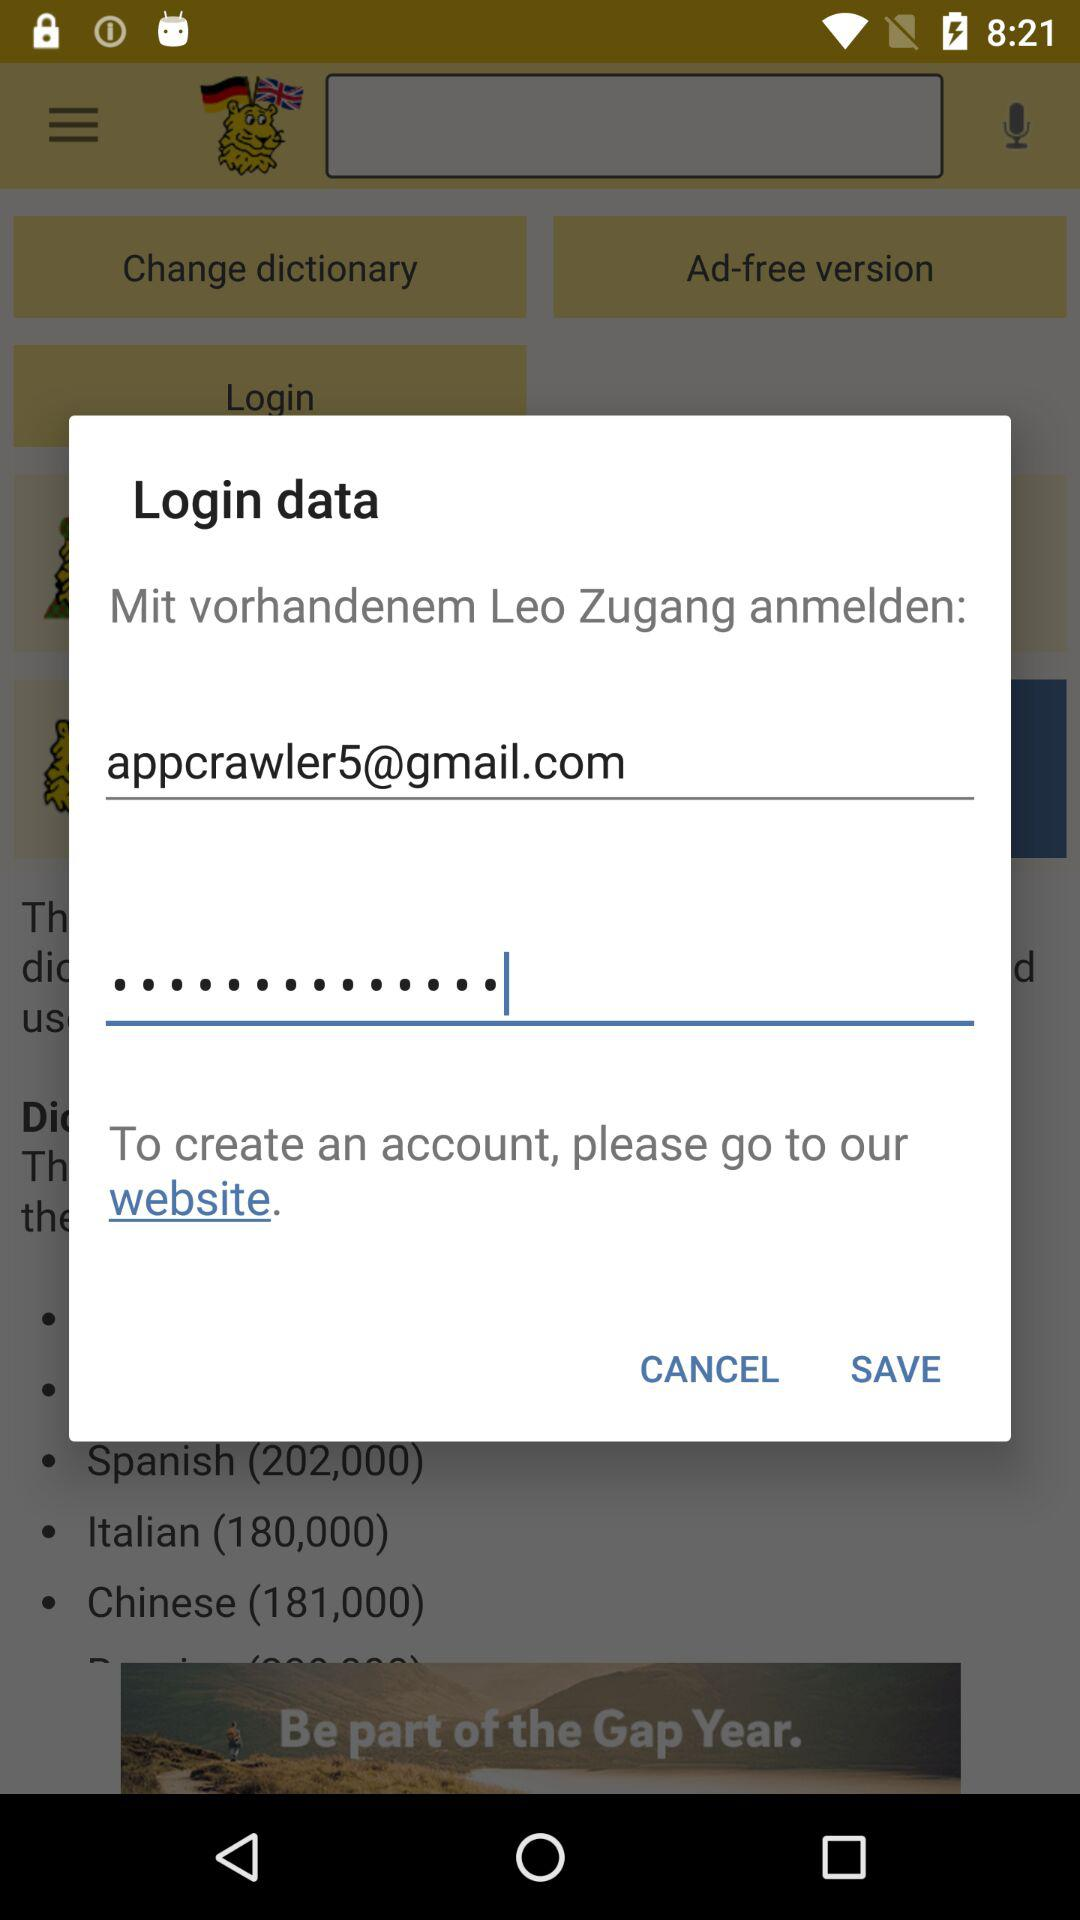What is the email address shown on the app? The email address shown on the app is appcrawler5@gmail.com. 